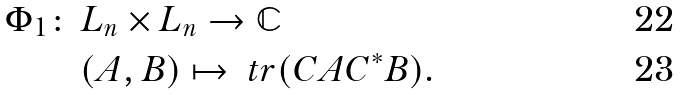Convert formula to latex. <formula><loc_0><loc_0><loc_500><loc_500>\Phi _ { 1 } \colon \, & L _ { n } \times L _ { n } \to { \mathbb { C } } \\ & ( A , B ) \mapsto \ t r ( C A C ^ { \ast } B ) .</formula> 